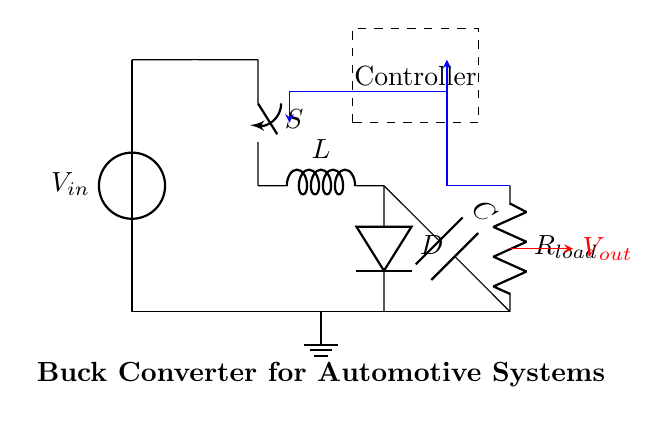What type of converter is this? This circuit diagram represents a buck converter, which is a type of DC-DC converter designed to step down voltage. The arrangement of components including a switch, inductor, diode, and capacitor confirms that it specifically functions as a buck converter.
Answer: Buck converter What is the main function of the inductor in this circuit? In a buck converter, the inductor's primary role is to store energy when the switch is closed and release it to the load when the switch is open. It helps in controlling the output voltage and smoothing the current supplied to the load.
Answer: Energy storage What is the purpose of the diode in this buck converter? The diode serves as a path for current when the switch is turned off. It allows the inductor's stored energy to discharge into the load, preventing a reverse current and ensuring that the converter can maintain a steady output voltage during the switching cycles.
Answer: Current path How does the controller affect the performance of this circuit? The controller regulates the operation of the switch, adjusting its duty cycle based on the feedback from the output voltage. This fine-tuning allows the converter to maintain a constant output despite variations in load or input voltage, ensuring efficient power management.
Answer: Regulates switch operation What happens to the output voltage when the input voltage increases? When the input voltage increases, the output voltage typically increases as well, but the controller adjusts the switch's duty cycle to maintain the desired output voltage. If the feedback mechanism is effective, the output remains stable despite changes in the input voltage.
Answer: Output remains stable What is likely the value of the load resistor in this automotive application? Load resistors in automotive applications generally range from a few ohms to several hundred ohms, depending on the load specifications. Without additional information, an exact value cannot be pinpointed, but it should match the intended current draw of the system.
Answer: Several hundred ohms What does the feedback loop indicate about the circuit? The feedback loop indicates that the circuit is designed for voltage regulation, where the output is monitored and compared to a reference voltage. This mechanism allows for adjustments to maintain output stability and improve efficiency during operation.
Answer: Voltage regulation 